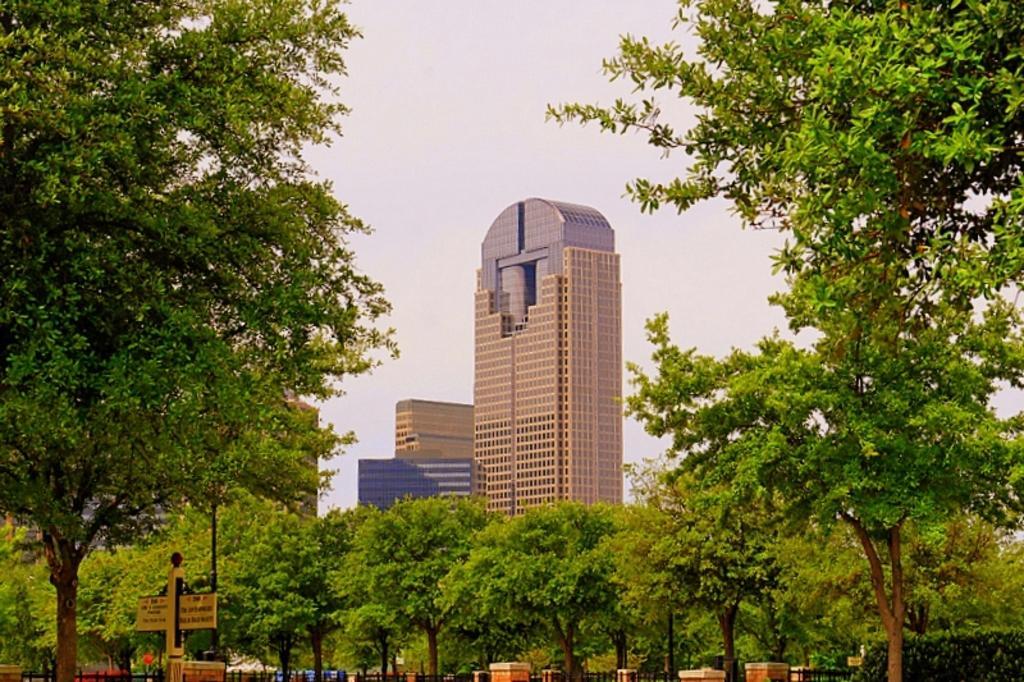Please provide a concise description of this image. This picture is clicked outside. In the foreground we can see the trees and the text on the board and we can see the metal rods and some other objects. In the background we can see the sky and the buildings and a lamp post. 